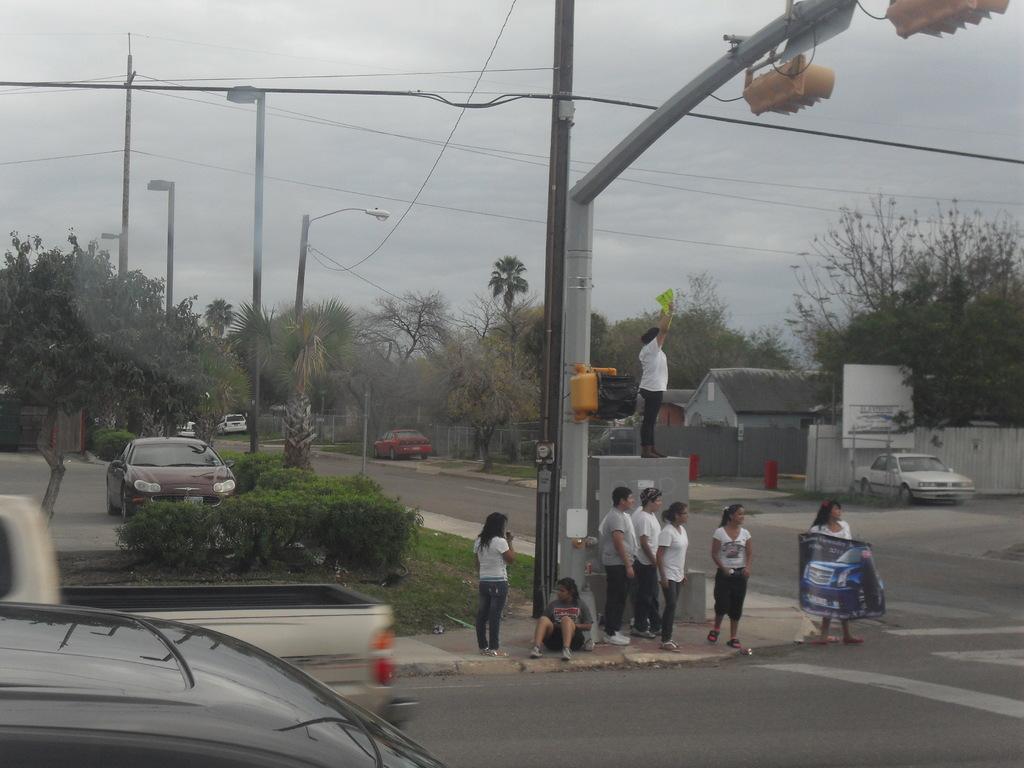Describe this image in one or two sentences. In this image we can see trees, street lights, traffic signal, cars, houses and road. In the middle of the road people are standing, they are wearing white color t-shirt. One woman is holding banner in her hand. 